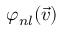<formula> <loc_0><loc_0><loc_500><loc_500>\varphi _ { n l } ( \vec { v } )</formula> 